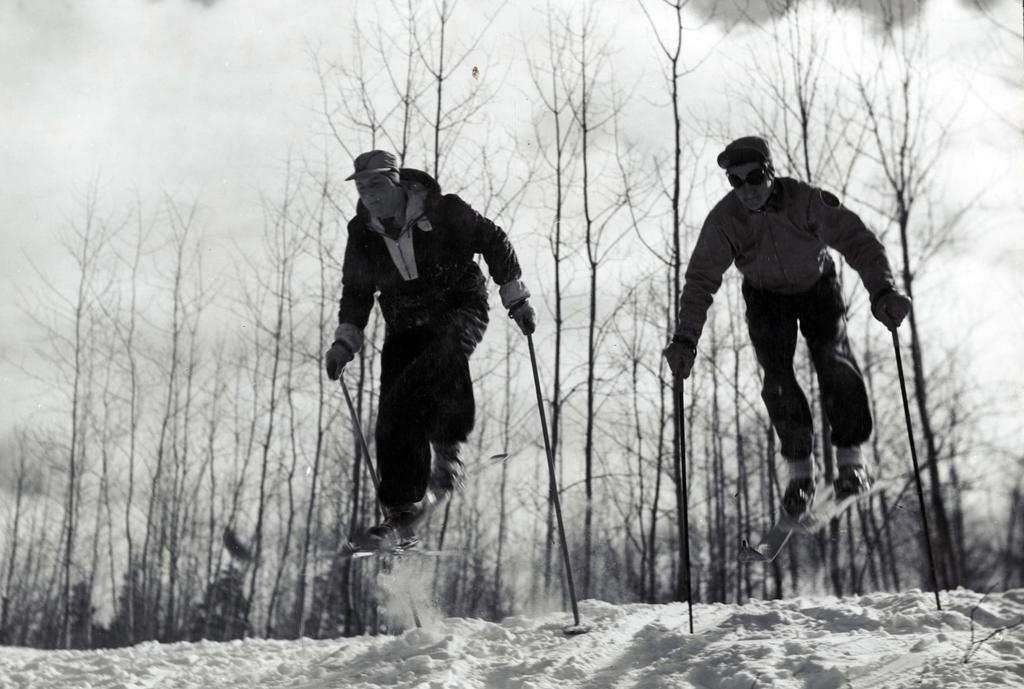What is the color scheme of the image? The image is black and white. What activity are the persons in the image engaged in? The persons in the image are skiing. On what surface are they skiing? They are skiing on snow. What can be seen in the background of the image? There are trees and the sky visible in the background of the image. What is the condition of the sky in the image? Clouds are present in the sky. What type of steam is being produced by the laborer in the image? There is no laborer or steam present in the image; it features persons skiing on snow. What is the desire of the person skiing in the image? The image does not provide information about the desires or intentions of the persons skiing. 